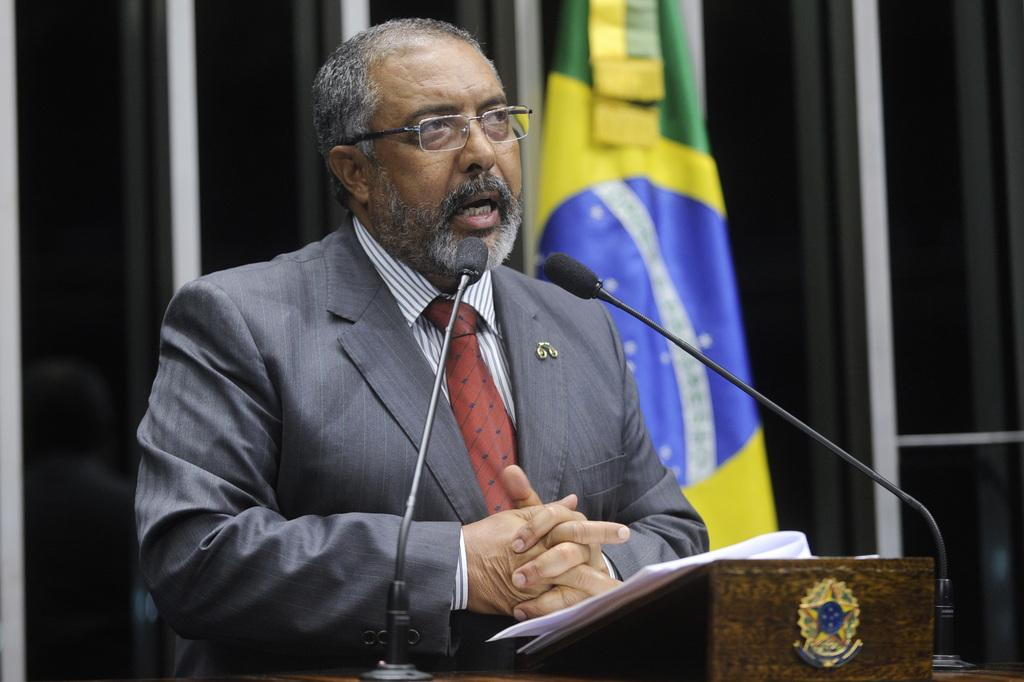What is the man in the image standing beside? The man is standing beside a speaker stand. What can be found on the speaker stand? The speaker stand contains mikes and papers. What type of material is visible in the image? Metal poles are visible in the image. What is the flag's position in the image? There is a flag in the image. What type of pin is holding the pancake to the flag in the image? There is no pin or pancake present in the image. The flag is not associated with a pancake, and there is no mention of a pin holding anything together. 